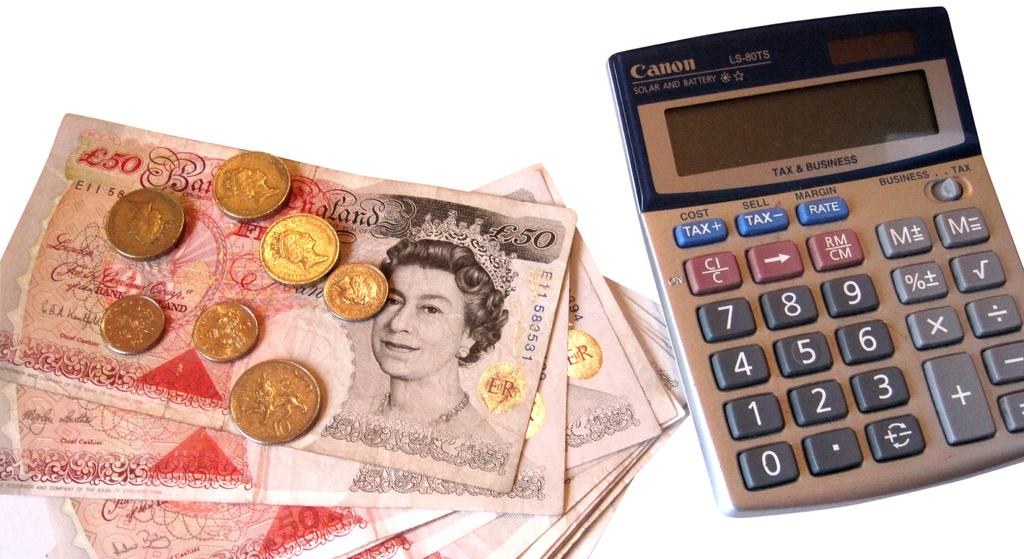<image>
Provide a brief description of the given image. A Cannon calculator and some foreign coins and bills with a picture of a lady. 